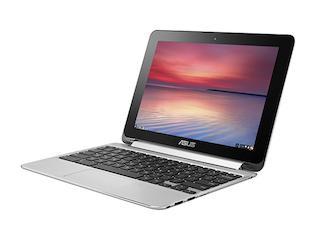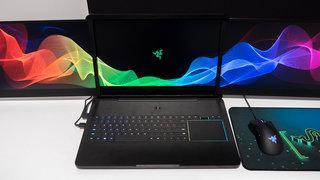The first image is the image on the left, the second image is the image on the right. For the images shown, is this caption "An image shows a back-to-front row of three keyboards with opened screens displaying various bright colors." true? Answer yes or no. No. The first image is the image on the left, the second image is the image on the right. Analyze the images presented: Is the assertion "One laptop is opened up in one of the images." valid? Answer yes or no. Yes. 